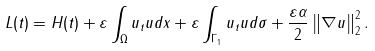Convert formula to latex. <formula><loc_0><loc_0><loc_500><loc_500>L ( t ) = H ( t ) + \varepsilon \int _ { \Omega } u _ { t } u d x + \varepsilon \int _ { \Gamma _ { 1 } } u _ { t } u d \sigma + \frac { \varepsilon \alpha } { 2 } \left \| \nabla u \right \| _ { 2 } ^ { 2 } .</formula> 